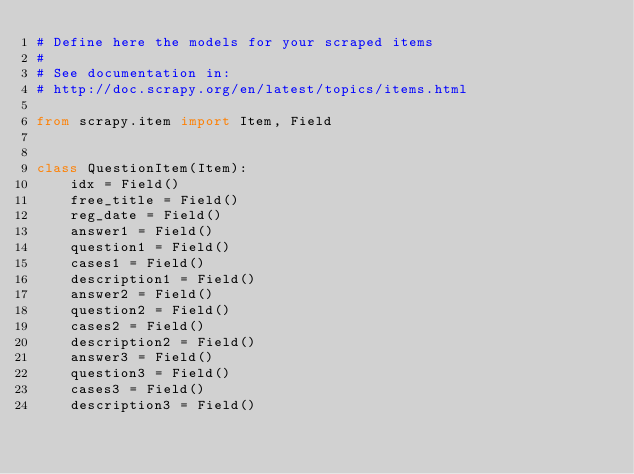Convert code to text. <code><loc_0><loc_0><loc_500><loc_500><_Python_># Define here the models for your scraped items
#
# See documentation in:
# http://doc.scrapy.org/en/latest/topics/items.html

from scrapy.item import Item, Field


class QuestionItem(Item):
    idx = Field()
    free_title = Field()
    reg_date = Field()
    answer1 = Field()
    question1 = Field()
    cases1 = Field()
    description1 = Field()
    answer2 = Field()
    question2 = Field()
    cases2 = Field()
    description2 = Field()
    answer3 = Field()
    question3 = Field()
    cases3 = Field()
    description3 = Field()
</code> 